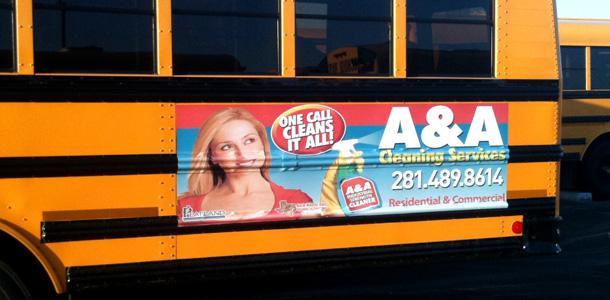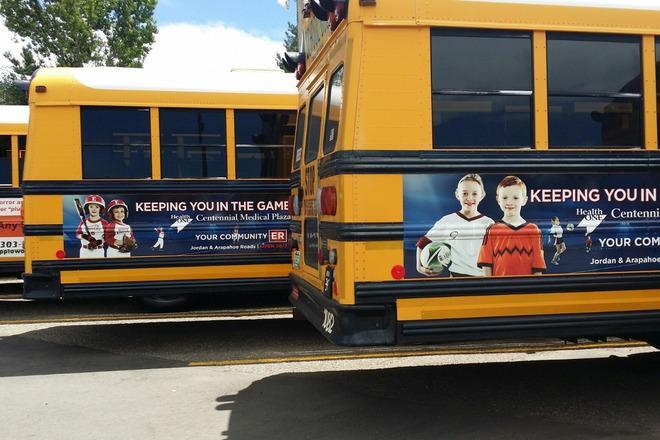The first image is the image on the left, the second image is the image on the right. Considering the images on both sides, is "All images show a sign on the side of a school bus that contains at least one human face, and at least one image features a school bus sign with multiple kids faces on it." valid? Answer yes or no. Yes. The first image is the image on the left, the second image is the image on the right. Evaluate the accuracy of this statement regarding the images: "There is a bus with at least one shild in the advertizing on the side of the bus". Is it true? Answer yes or no. Yes. 